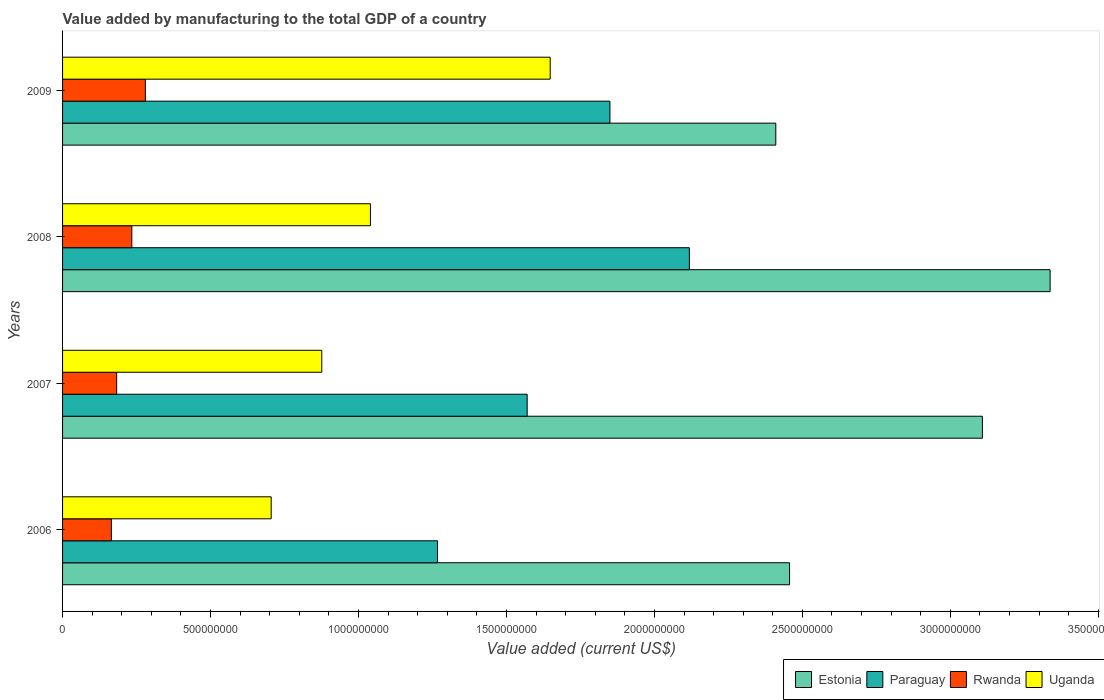How many different coloured bars are there?
Offer a very short reply. 4. How many groups of bars are there?
Your answer should be compact. 4. What is the label of the 4th group of bars from the top?
Provide a succinct answer. 2006. In how many cases, is the number of bars for a given year not equal to the number of legend labels?
Give a very brief answer. 0. What is the value added by manufacturing to the total GDP in Estonia in 2007?
Provide a succinct answer. 3.11e+09. Across all years, what is the maximum value added by manufacturing to the total GDP in Uganda?
Provide a succinct answer. 1.65e+09. Across all years, what is the minimum value added by manufacturing to the total GDP in Estonia?
Ensure brevity in your answer.  2.41e+09. In which year was the value added by manufacturing to the total GDP in Uganda minimum?
Make the answer very short. 2006. What is the total value added by manufacturing to the total GDP in Estonia in the graph?
Provide a succinct answer. 1.13e+1. What is the difference between the value added by manufacturing to the total GDP in Rwanda in 2008 and that in 2009?
Offer a very short reply. -4.57e+07. What is the difference between the value added by manufacturing to the total GDP in Paraguay in 2009 and the value added by manufacturing to the total GDP in Estonia in 2008?
Offer a very short reply. -1.49e+09. What is the average value added by manufacturing to the total GDP in Rwanda per year?
Provide a succinct answer. 2.15e+08. In the year 2008, what is the difference between the value added by manufacturing to the total GDP in Rwanda and value added by manufacturing to the total GDP in Uganda?
Provide a short and direct response. -8.06e+08. In how many years, is the value added by manufacturing to the total GDP in Estonia greater than 2500000000 US$?
Give a very brief answer. 2. What is the ratio of the value added by manufacturing to the total GDP in Paraguay in 2008 to that in 2009?
Give a very brief answer. 1.15. What is the difference between the highest and the second highest value added by manufacturing to the total GDP in Uganda?
Keep it short and to the point. 6.07e+08. What is the difference between the highest and the lowest value added by manufacturing to the total GDP in Uganda?
Provide a short and direct response. 9.43e+08. Is it the case that in every year, the sum of the value added by manufacturing to the total GDP in Uganda and value added by manufacturing to the total GDP in Estonia is greater than the sum of value added by manufacturing to the total GDP in Rwanda and value added by manufacturing to the total GDP in Paraguay?
Offer a terse response. Yes. What does the 1st bar from the top in 2009 represents?
Make the answer very short. Uganda. What does the 4th bar from the bottom in 2008 represents?
Make the answer very short. Uganda. How many years are there in the graph?
Provide a short and direct response. 4. What is the difference between two consecutive major ticks on the X-axis?
Your response must be concise. 5.00e+08. Does the graph contain any zero values?
Your answer should be very brief. No. Does the graph contain grids?
Your response must be concise. No. Where does the legend appear in the graph?
Provide a short and direct response. Bottom right. What is the title of the graph?
Your answer should be compact. Value added by manufacturing to the total GDP of a country. What is the label or title of the X-axis?
Offer a terse response. Value added (current US$). What is the label or title of the Y-axis?
Keep it short and to the point. Years. What is the Value added (current US$) of Estonia in 2006?
Ensure brevity in your answer.  2.46e+09. What is the Value added (current US$) of Paraguay in 2006?
Your response must be concise. 1.27e+09. What is the Value added (current US$) in Rwanda in 2006?
Ensure brevity in your answer.  1.65e+08. What is the Value added (current US$) of Uganda in 2006?
Ensure brevity in your answer.  7.05e+08. What is the Value added (current US$) of Estonia in 2007?
Provide a short and direct response. 3.11e+09. What is the Value added (current US$) of Paraguay in 2007?
Ensure brevity in your answer.  1.57e+09. What is the Value added (current US$) of Rwanda in 2007?
Offer a very short reply. 1.83e+08. What is the Value added (current US$) of Uganda in 2007?
Provide a succinct answer. 8.76e+08. What is the Value added (current US$) of Estonia in 2008?
Keep it short and to the point. 3.34e+09. What is the Value added (current US$) of Paraguay in 2008?
Offer a terse response. 2.12e+09. What is the Value added (current US$) of Rwanda in 2008?
Give a very brief answer. 2.34e+08. What is the Value added (current US$) of Uganda in 2008?
Provide a succinct answer. 1.04e+09. What is the Value added (current US$) in Estonia in 2009?
Provide a succinct answer. 2.41e+09. What is the Value added (current US$) in Paraguay in 2009?
Your answer should be compact. 1.85e+09. What is the Value added (current US$) of Rwanda in 2009?
Make the answer very short. 2.80e+08. What is the Value added (current US$) of Uganda in 2009?
Your answer should be very brief. 1.65e+09. Across all years, what is the maximum Value added (current US$) of Estonia?
Your answer should be compact. 3.34e+09. Across all years, what is the maximum Value added (current US$) in Paraguay?
Give a very brief answer. 2.12e+09. Across all years, what is the maximum Value added (current US$) of Rwanda?
Keep it short and to the point. 2.80e+08. Across all years, what is the maximum Value added (current US$) in Uganda?
Your response must be concise. 1.65e+09. Across all years, what is the minimum Value added (current US$) in Estonia?
Your answer should be compact. 2.41e+09. Across all years, what is the minimum Value added (current US$) in Paraguay?
Provide a short and direct response. 1.27e+09. Across all years, what is the minimum Value added (current US$) of Rwanda?
Keep it short and to the point. 1.65e+08. Across all years, what is the minimum Value added (current US$) of Uganda?
Provide a succinct answer. 7.05e+08. What is the total Value added (current US$) in Estonia in the graph?
Offer a terse response. 1.13e+1. What is the total Value added (current US$) of Paraguay in the graph?
Your answer should be compact. 6.81e+09. What is the total Value added (current US$) of Rwanda in the graph?
Offer a terse response. 8.62e+08. What is the total Value added (current US$) of Uganda in the graph?
Provide a short and direct response. 4.27e+09. What is the difference between the Value added (current US$) of Estonia in 2006 and that in 2007?
Make the answer very short. -6.52e+08. What is the difference between the Value added (current US$) of Paraguay in 2006 and that in 2007?
Keep it short and to the point. -3.03e+08. What is the difference between the Value added (current US$) in Rwanda in 2006 and that in 2007?
Ensure brevity in your answer.  -1.79e+07. What is the difference between the Value added (current US$) of Uganda in 2006 and that in 2007?
Your answer should be very brief. -1.71e+08. What is the difference between the Value added (current US$) in Estonia in 2006 and that in 2008?
Give a very brief answer. -8.80e+08. What is the difference between the Value added (current US$) in Paraguay in 2006 and that in 2008?
Provide a short and direct response. -8.51e+08. What is the difference between the Value added (current US$) of Rwanda in 2006 and that in 2008?
Ensure brevity in your answer.  -6.91e+07. What is the difference between the Value added (current US$) in Uganda in 2006 and that in 2008?
Your response must be concise. -3.35e+08. What is the difference between the Value added (current US$) in Estonia in 2006 and that in 2009?
Ensure brevity in your answer.  4.66e+07. What is the difference between the Value added (current US$) in Paraguay in 2006 and that in 2009?
Provide a succinct answer. -5.83e+08. What is the difference between the Value added (current US$) of Rwanda in 2006 and that in 2009?
Your answer should be very brief. -1.15e+08. What is the difference between the Value added (current US$) of Uganda in 2006 and that in 2009?
Your response must be concise. -9.43e+08. What is the difference between the Value added (current US$) of Estonia in 2007 and that in 2008?
Offer a very short reply. -2.29e+08. What is the difference between the Value added (current US$) in Paraguay in 2007 and that in 2008?
Offer a very short reply. -5.48e+08. What is the difference between the Value added (current US$) in Rwanda in 2007 and that in 2008?
Your answer should be compact. -5.12e+07. What is the difference between the Value added (current US$) of Uganda in 2007 and that in 2008?
Offer a terse response. -1.64e+08. What is the difference between the Value added (current US$) in Estonia in 2007 and that in 2009?
Make the answer very short. 6.98e+08. What is the difference between the Value added (current US$) in Paraguay in 2007 and that in 2009?
Offer a very short reply. -2.80e+08. What is the difference between the Value added (current US$) in Rwanda in 2007 and that in 2009?
Make the answer very short. -9.70e+07. What is the difference between the Value added (current US$) in Uganda in 2007 and that in 2009?
Your answer should be very brief. -7.72e+08. What is the difference between the Value added (current US$) of Estonia in 2008 and that in 2009?
Keep it short and to the point. 9.27e+08. What is the difference between the Value added (current US$) of Paraguay in 2008 and that in 2009?
Your answer should be compact. 2.68e+08. What is the difference between the Value added (current US$) of Rwanda in 2008 and that in 2009?
Your response must be concise. -4.57e+07. What is the difference between the Value added (current US$) of Uganda in 2008 and that in 2009?
Make the answer very short. -6.07e+08. What is the difference between the Value added (current US$) in Estonia in 2006 and the Value added (current US$) in Paraguay in 2007?
Your answer should be compact. 8.87e+08. What is the difference between the Value added (current US$) of Estonia in 2006 and the Value added (current US$) of Rwanda in 2007?
Offer a very short reply. 2.27e+09. What is the difference between the Value added (current US$) in Estonia in 2006 and the Value added (current US$) in Uganda in 2007?
Your answer should be compact. 1.58e+09. What is the difference between the Value added (current US$) in Paraguay in 2006 and the Value added (current US$) in Rwanda in 2007?
Ensure brevity in your answer.  1.08e+09. What is the difference between the Value added (current US$) in Paraguay in 2006 and the Value added (current US$) in Uganda in 2007?
Your answer should be very brief. 3.91e+08. What is the difference between the Value added (current US$) of Rwanda in 2006 and the Value added (current US$) of Uganda in 2007?
Your answer should be very brief. -7.11e+08. What is the difference between the Value added (current US$) in Estonia in 2006 and the Value added (current US$) in Paraguay in 2008?
Offer a very short reply. 3.39e+08. What is the difference between the Value added (current US$) in Estonia in 2006 and the Value added (current US$) in Rwanda in 2008?
Make the answer very short. 2.22e+09. What is the difference between the Value added (current US$) of Estonia in 2006 and the Value added (current US$) of Uganda in 2008?
Keep it short and to the point. 1.42e+09. What is the difference between the Value added (current US$) of Paraguay in 2006 and the Value added (current US$) of Rwanda in 2008?
Give a very brief answer. 1.03e+09. What is the difference between the Value added (current US$) in Paraguay in 2006 and the Value added (current US$) in Uganda in 2008?
Make the answer very short. 2.27e+08. What is the difference between the Value added (current US$) of Rwanda in 2006 and the Value added (current US$) of Uganda in 2008?
Give a very brief answer. -8.75e+08. What is the difference between the Value added (current US$) of Estonia in 2006 and the Value added (current US$) of Paraguay in 2009?
Make the answer very short. 6.07e+08. What is the difference between the Value added (current US$) of Estonia in 2006 and the Value added (current US$) of Rwanda in 2009?
Give a very brief answer. 2.18e+09. What is the difference between the Value added (current US$) of Estonia in 2006 and the Value added (current US$) of Uganda in 2009?
Make the answer very short. 8.09e+08. What is the difference between the Value added (current US$) of Paraguay in 2006 and the Value added (current US$) of Rwanda in 2009?
Provide a short and direct response. 9.87e+08. What is the difference between the Value added (current US$) of Paraguay in 2006 and the Value added (current US$) of Uganda in 2009?
Give a very brief answer. -3.81e+08. What is the difference between the Value added (current US$) in Rwanda in 2006 and the Value added (current US$) in Uganda in 2009?
Provide a short and direct response. -1.48e+09. What is the difference between the Value added (current US$) in Estonia in 2007 and the Value added (current US$) in Paraguay in 2008?
Provide a short and direct response. 9.90e+08. What is the difference between the Value added (current US$) of Estonia in 2007 and the Value added (current US$) of Rwanda in 2008?
Offer a terse response. 2.87e+09. What is the difference between the Value added (current US$) of Estonia in 2007 and the Value added (current US$) of Uganda in 2008?
Your response must be concise. 2.07e+09. What is the difference between the Value added (current US$) of Paraguay in 2007 and the Value added (current US$) of Rwanda in 2008?
Your response must be concise. 1.34e+09. What is the difference between the Value added (current US$) of Paraguay in 2007 and the Value added (current US$) of Uganda in 2008?
Ensure brevity in your answer.  5.30e+08. What is the difference between the Value added (current US$) of Rwanda in 2007 and the Value added (current US$) of Uganda in 2008?
Offer a very short reply. -8.58e+08. What is the difference between the Value added (current US$) in Estonia in 2007 and the Value added (current US$) in Paraguay in 2009?
Your answer should be compact. 1.26e+09. What is the difference between the Value added (current US$) of Estonia in 2007 and the Value added (current US$) of Rwanda in 2009?
Offer a very short reply. 2.83e+09. What is the difference between the Value added (current US$) in Estonia in 2007 and the Value added (current US$) in Uganda in 2009?
Ensure brevity in your answer.  1.46e+09. What is the difference between the Value added (current US$) in Paraguay in 2007 and the Value added (current US$) in Rwanda in 2009?
Keep it short and to the point. 1.29e+09. What is the difference between the Value added (current US$) of Paraguay in 2007 and the Value added (current US$) of Uganda in 2009?
Offer a terse response. -7.78e+07. What is the difference between the Value added (current US$) of Rwanda in 2007 and the Value added (current US$) of Uganda in 2009?
Offer a very short reply. -1.47e+09. What is the difference between the Value added (current US$) in Estonia in 2008 and the Value added (current US$) in Paraguay in 2009?
Provide a succinct answer. 1.49e+09. What is the difference between the Value added (current US$) of Estonia in 2008 and the Value added (current US$) of Rwanda in 2009?
Your response must be concise. 3.06e+09. What is the difference between the Value added (current US$) of Estonia in 2008 and the Value added (current US$) of Uganda in 2009?
Your answer should be compact. 1.69e+09. What is the difference between the Value added (current US$) in Paraguay in 2008 and the Value added (current US$) in Rwanda in 2009?
Provide a succinct answer. 1.84e+09. What is the difference between the Value added (current US$) of Paraguay in 2008 and the Value added (current US$) of Uganda in 2009?
Provide a short and direct response. 4.70e+08. What is the difference between the Value added (current US$) of Rwanda in 2008 and the Value added (current US$) of Uganda in 2009?
Make the answer very short. -1.41e+09. What is the average Value added (current US$) of Estonia per year?
Ensure brevity in your answer.  2.83e+09. What is the average Value added (current US$) in Paraguay per year?
Keep it short and to the point. 1.70e+09. What is the average Value added (current US$) of Rwanda per year?
Give a very brief answer. 2.15e+08. What is the average Value added (current US$) in Uganda per year?
Your answer should be very brief. 1.07e+09. In the year 2006, what is the difference between the Value added (current US$) in Estonia and Value added (current US$) in Paraguay?
Provide a succinct answer. 1.19e+09. In the year 2006, what is the difference between the Value added (current US$) of Estonia and Value added (current US$) of Rwanda?
Your answer should be compact. 2.29e+09. In the year 2006, what is the difference between the Value added (current US$) of Estonia and Value added (current US$) of Uganda?
Keep it short and to the point. 1.75e+09. In the year 2006, what is the difference between the Value added (current US$) in Paraguay and Value added (current US$) in Rwanda?
Offer a terse response. 1.10e+09. In the year 2006, what is the difference between the Value added (current US$) in Paraguay and Value added (current US$) in Uganda?
Offer a terse response. 5.62e+08. In the year 2006, what is the difference between the Value added (current US$) of Rwanda and Value added (current US$) of Uganda?
Provide a succinct answer. -5.40e+08. In the year 2007, what is the difference between the Value added (current US$) in Estonia and Value added (current US$) in Paraguay?
Keep it short and to the point. 1.54e+09. In the year 2007, what is the difference between the Value added (current US$) in Estonia and Value added (current US$) in Rwanda?
Offer a very short reply. 2.93e+09. In the year 2007, what is the difference between the Value added (current US$) in Estonia and Value added (current US$) in Uganda?
Your answer should be very brief. 2.23e+09. In the year 2007, what is the difference between the Value added (current US$) in Paraguay and Value added (current US$) in Rwanda?
Give a very brief answer. 1.39e+09. In the year 2007, what is the difference between the Value added (current US$) in Paraguay and Value added (current US$) in Uganda?
Offer a very short reply. 6.94e+08. In the year 2007, what is the difference between the Value added (current US$) in Rwanda and Value added (current US$) in Uganda?
Your answer should be compact. -6.93e+08. In the year 2008, what is the difference between the Value added (current US$) of Estonia and Value added (current US$) of Paraguay?
Provide a short and direct response. 1.22e+09. In the year 2008, what is the difference between the Value added (current US$) in Estonia and Value added (current US$) in Rwanda?
Offer a very short reply. 3.10e+09. In the year 2008, what is the difference between the Value added (current US$) in Estonia and Value added (current US$) in Uganda?
Make the answer very short. 2.30e+09. In the year 2008, what is the difference between the Value added (current US$) of Paraguay and Value added (current US$) of Rwanda?
Give a very brief answer. 1.88e+09. In the year 2008, what is the difference between the Value added (current US$) in Paraguay and Value added (current US$) in Uganda?
Give a very brief answer. 1.08e+09. In the year 2008, what is the difference between the Value added (current US$) in Rwanda and Value added (current US$) in Uganda?
Offer a very short reply. -8.06e+08. In the year 2009, what is the difference between the Value added (current US$) of Estonia and Value added (current US$) of Paraguay?
Provide a short and direct response. 5.61e+08. In the year 2009, what is the difference between the Value added (current US$) in Estonia and Value added (current US$) in Rwanda?
Offer a terse response. 2.13e+09. In the year 2009, what is the difference between the Value added (current US$) of Estonia and Value added (current US$) of Uganda?
Make the answer very short. 7.62e+08. In the year 2009, what is the difference between the Value added (current US$) in Paraguay and Value added (current US$) in Rwanda?
Provide a short and direct response. 1.57e+09. In the year 2009, what is the difference between the Value added (current US$) of Paraguay and Value added (current US$) of Uganda?
Offer a terse response. 2.02e+08. In the year 2009, what is the difference between the Value added (current US$) of Rwanda and Value added (current US$) of Uganda?
Offer a very short reply. -1.37e+09. What is the ratio of the Value added (current US$) in Estonia in 2006 to that in 2007?
Offer a very short reply. 0.79. What is the ratio of the Value added (current US$) in Paraguay in 2006 to that in 2007?
Provide a succinct answer. 0.81. What is the ratio of the Value added (current US$) in Rwanda in 2006 to that in 2007?
Your answer should be very brief. 0.9. What is the ratio of the Value added (current US$) of Uganda in 2006 to that in 2007?
Make the answer very short. 0.8. What is the ratio of the Value added (current US$) of Estonia in 2006 to that in 2008?
Give a very brief answer. 0.74. What is the ratio of the Value added (current US$) in Paraguay in 2006 to that in 2008?
Your answer should be very brief. 0.6. What is the ratio of the Value added (current US$) of Rwanda in 2006 to that in 2008?
Your answer should be very brief. 0.7. What is the ratio of the Value added (current US$) of Uganda in 2006 to that in 2008?
Offer a terse response. 0.68. What is the ratio of the Value added (current US$) of Estonia in 2006 to that in 2009?
Provide a short and direct response. 1.02. What is the ratio of the Value added (current US$) in Paraguay in 2006 to that in 2009?
Make the answer very short. 0.69. What is the ratio of the Value added (current US$) in Rwanda in 2006 to that in 2009?
Offer a terse response. 0.59. What is the ratio of the Value added (current US$) of Uganda in 2006 to that in 2009?
Ensure brevity in your answer.  0.43. What is the ratio of the Value added (current US$) in Estonia in 2007 to that in 2008?
Your response must be concise. 0.93. What is the ratio of the Value added (current US$) in Paraguay in 2007 to that in 2008?
Provide a short and direct response. 0.74. What is the ratio of the Value added (current US$) of Rwanda in 2007 to that in 2008?
Make the answer very short. 0.78. What is the ratio of the Value added (current US$) of Uganda in 2007 to that in 2008?
Provide a short and direct response. 0.84. What is the ratio of the Value added (current US$) in Estonia in 2007 to that in 2009?
Offer a terse response. 1.29. What is the ratio of the Value added (current US$) in Paraguay in 2007 to that in 2009?
Give a very brief answer. 0.85. What is the ratio of the Value added (current US$) in Rwanda in 2007 to that in 2009?
Offer a terse response. 0.65. What is the ratio of the Value added (current US$) in Uganda in 2007 to that in 2009?
Provide a succinct answer. 0.53. What is the ratio of the Value added (current US$) in Estonia in 2008 to that in 2009?
Offer a very short reply. 1.38. What is the ratio of the Value added (current US$) in Paraguay in 2008 to that in 2009?
Your answer should be very brief. 1.15. What is the ratio of the Value added (current US$) of Rwanda in 2008 to that in 2009?
Offer a terse response. 0.84. What is the ratio of the Value added (current US$) of Uganda in 2008 to that in 2009?
Make the answer very short. 0.63. What is the difference between the highest and the second highest Value added (current US$) in Estonia?
Your answer should be compact. 2.29e+08. What is the difference between the highest and the second highest Value added (current US$) in Paraguay?
Give a very brief answer. 2.68e+08. What is the difference between the highest and the second highest Value added (current US$) in Rwanda?
Provide a succinct answer. 4.57e+07. What is the difference between the highest and the second highest Value added (current US$) in Uganda?
Make the answer very short. 6.07e+08. What is the difference between the highest and the lowest Value added (current US$) of Estonia?
Offer a terse response. 9.27e+08. What is the difference between the highest and the lowest Value added (current US$) of Paraguay?
Your answer should be very brief. 8.51e+08. What is the difference between the highest and the lowest Value added (current US$) in Rwanda?
Provide a succinct answer. 1.15e+08. What is the difference between the highest and the lowest Value added (current US$) of Uganda?
Your answer should be compact. 9.43e+08. 